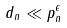Convert formula to latex. <formula><loc_0><loc_0><loc_500><loc_500>d _ { n } \ll p _ { n } ^ { \epsilon }</formula> 